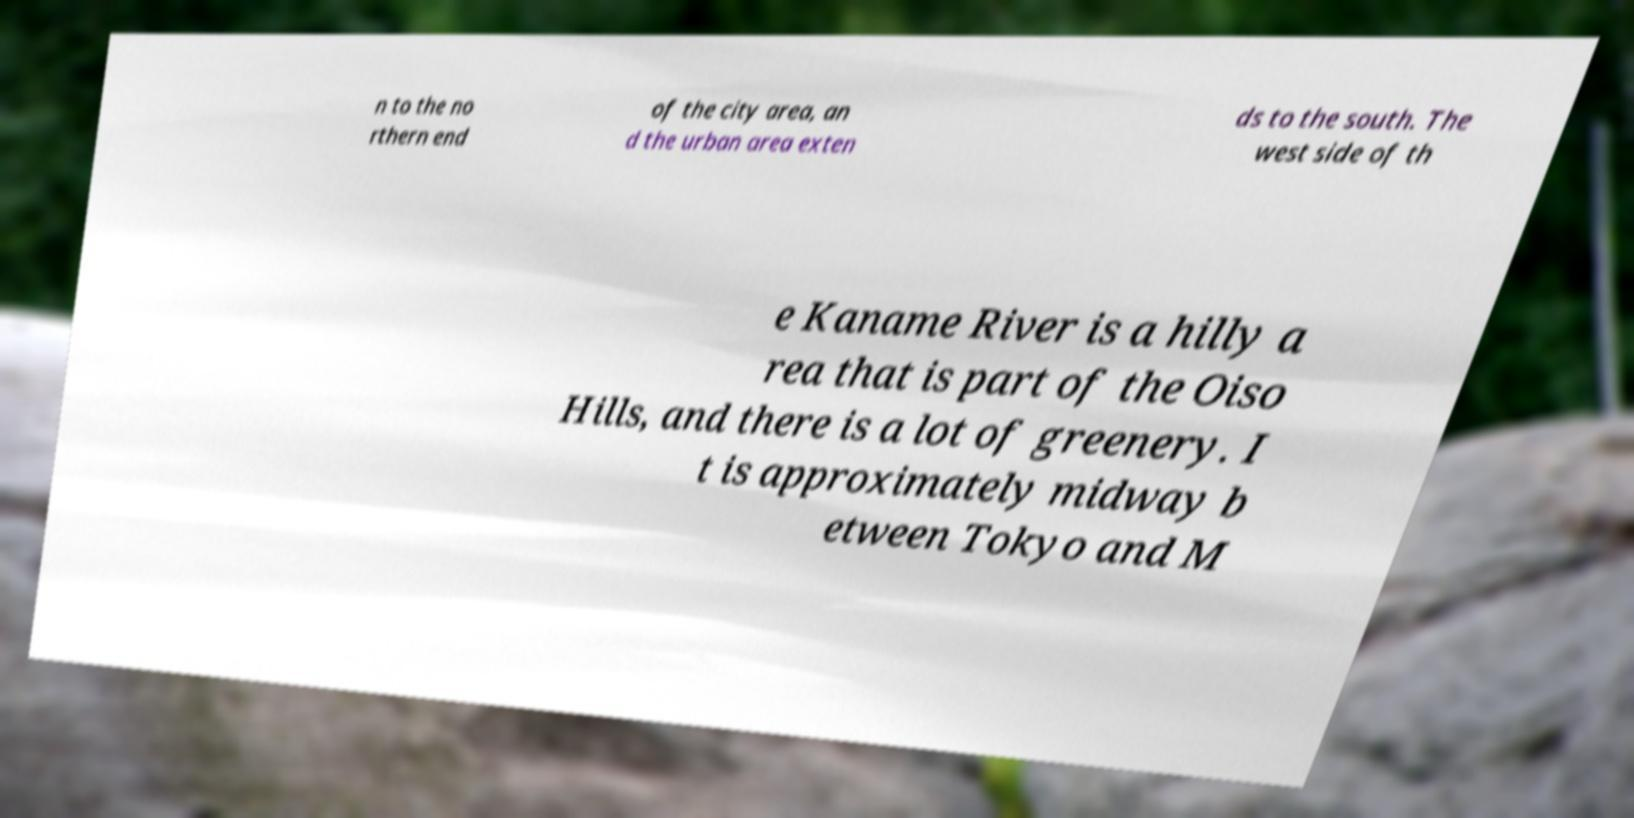Please identify and transcribe the text found in this image. n to the no rthern end of the city area, an d the urban area exten ds to the south. The west side of th e Kaname River is a hilly a rea that is part of the Oiso Hills, and there is a lot of greenery. I t is approximately midway b etween Tokyo and M 